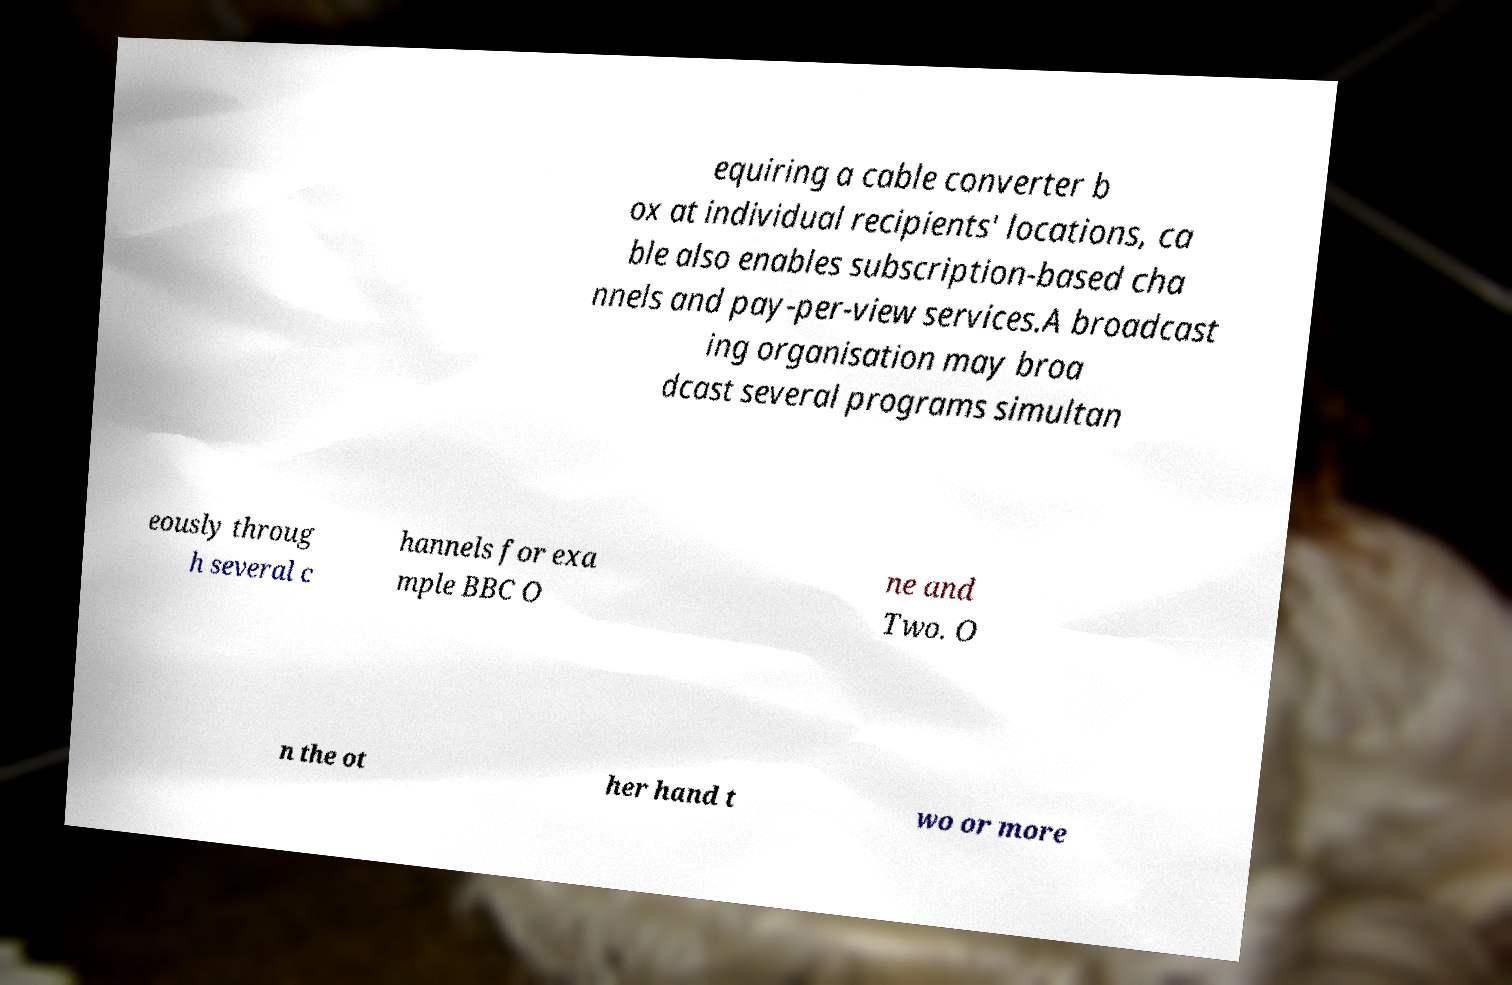For documentation purposes, I need the text within this image transcribed. Could you provide that? equiring a cable converter b ox at individual recipients' locations, ca ble also enables subscription-based cha nnels and pay-per-view services.A broadcast ing organisation may broa dcast several programs simultan eously throug h several c hannels for exa mple BBC O ne and Two. O n the ot her hand t wo or more 